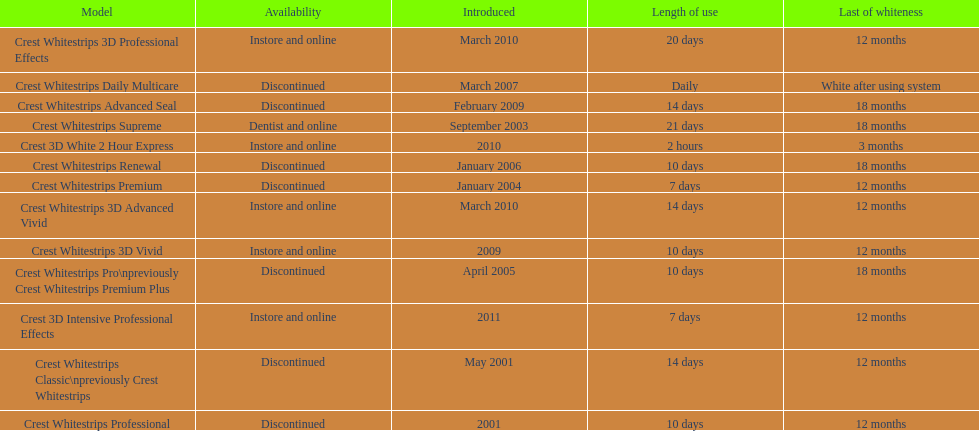What is the number of products that were introduced in 2010? 3. 